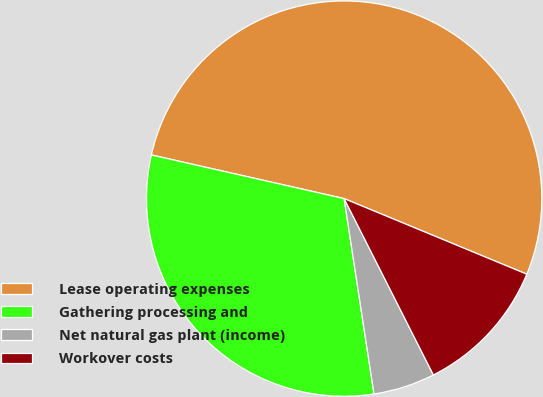Convert chart. <chart><loc_0><loc_0><loc_500><loc_500><pie_chart><fcel>Lease operating expenses<fcel>Gathering processing and<fcel>Net natural gas plant (income)<fcel>Workover costs<nl><fcel>52.7%<fcel>30.96%<fcel>5.04%<fcel>11.3%<nl></chart> 